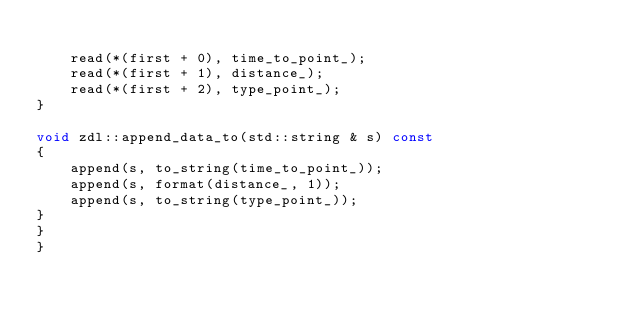<code> <loc_0><loc_0><loc_500><loc_500><_C++_>
	read(*(first + 0), time_to_point_);
	read(*(first + 1), distance_);
	read(*(first + 2), type_point_);
}

void zdl::append_data_to(std::string & s) const
{
	append(s, to_string(time_to_point_));
	append(s, format(distance_, 1));
	append(s, to_string(type_point_));
}
}
}
</code> 